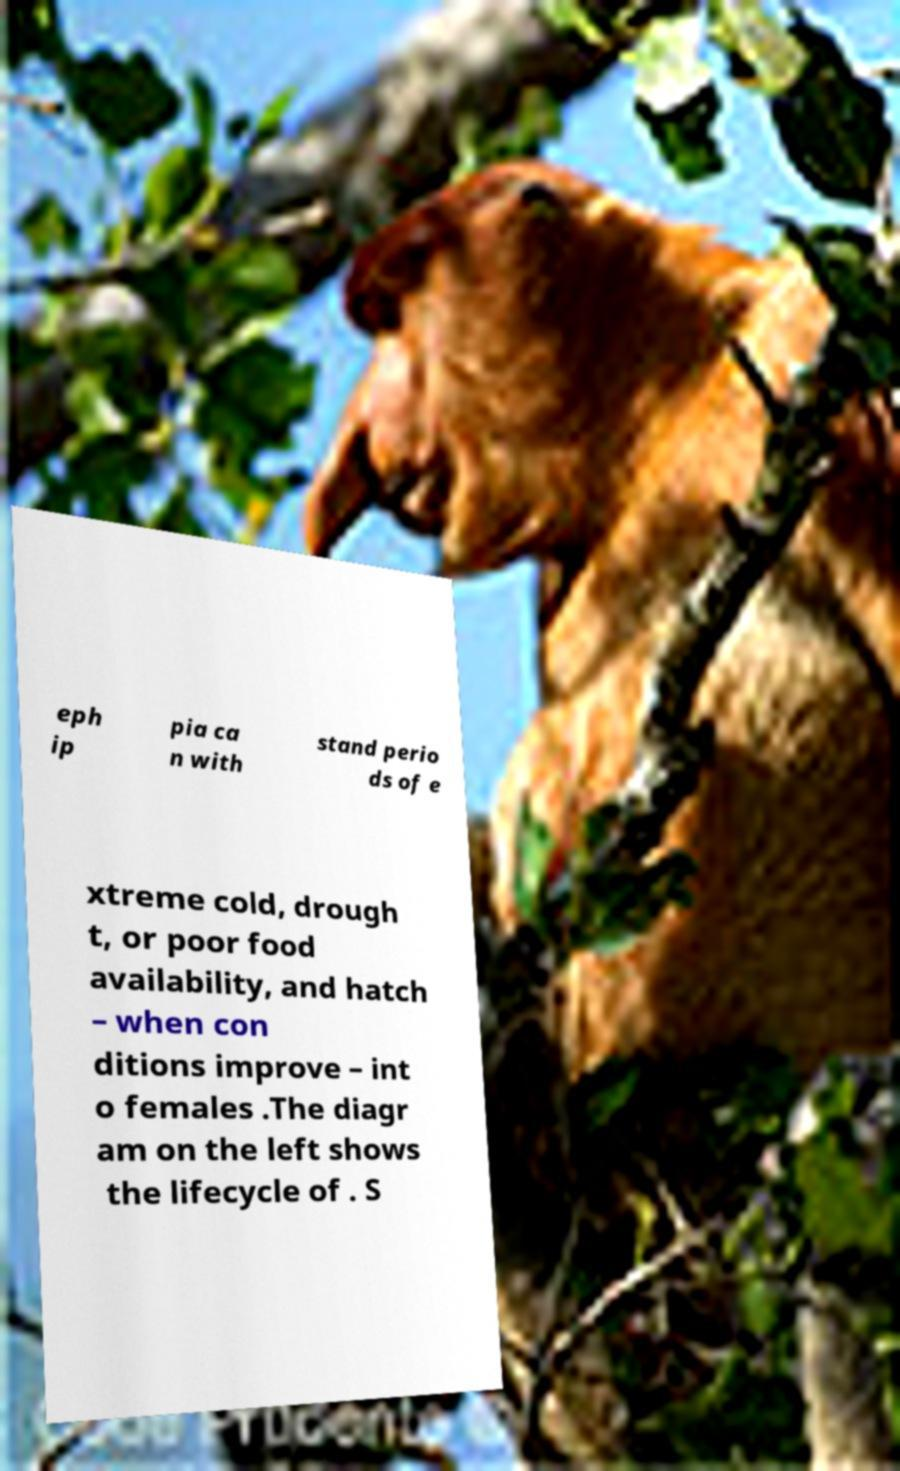I need the written content from this picture converted into text. Can you do that? eph ip pia ca n with stand perio ds of e xtreme cold, drough t, or poor food availability, and hatch – when con ditions improve – int o females .The diagr am on the left shows the lifecycle of . S 